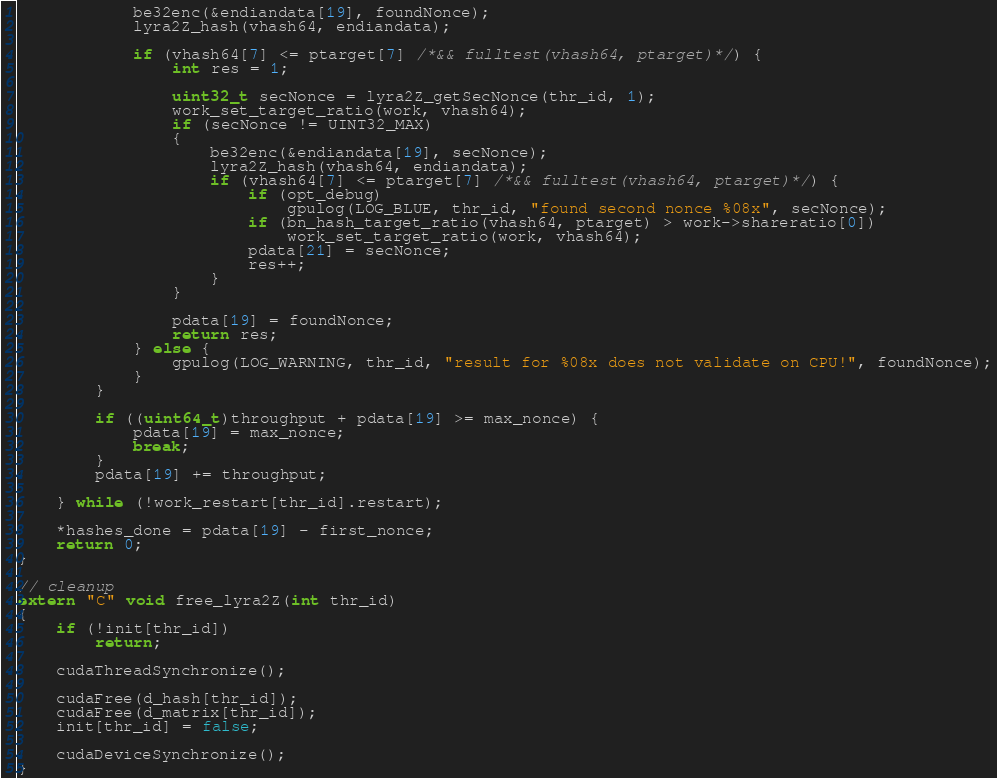<code> <loc_0><loc_0><loc_500><loc_500><_Cuda_>			be32enc(&endiandata[19], foundNonce); 
			lyra2Z_hash(vhash64, endiandata);  

			if (vhash64[7] <= ptarget[7] /*&& fulltest(vhash64, ptarget)*/) {
				int res = 1;
			
				uint32_t secNonce = lyra2Z_getSecNonce(thr_id, 1);
				work_set_target_ratio(work, vhash64);
				if (secNonce != UINT32_MAX)
				{
					be32enc(&endiandata[19], secNonce);
					lyra2Z_hash(vhash64, endiandata);
					if (vhash64[7] <= ptarget[7] /*&& fulltest(vhash64, ptarget)*/) {
						if (opt_debug)
							gpulog(LOG_BLUE, thr_id, "found second nonce %08x", secNonce);
						if (bn_hash_target_ratio(vhash64, ptarget) > work->shareratio[0])
							work_set_target_ratio(work, vhash64);
						pdata[21] = secNonce;
						res++;
					}
				}
			
				pdata[19] = foundNonce;
				return res;
			} else {
				gpulog(LOG_WARNING, thr_id, "result for %08x does not validate on CPU!", foundNonce);
			}
		}

		if ((uint64_t)throughput + pdata[19] >= max_nonce) {
			pdata[19] = max_nonce;
			break;
		}
		pdata[19] += throughput;

	} while (!work_restart[thr_id].restart);

	*hashes_done = pdata[19] - first_nonce;
	return 0;
}

// cleanup
extern "C" void free_lyra2Z(int thr_id)
{
	if (!init[thr_id])
		return;

	cudaThreadSynchronize();

	cudaFree(d_hash[thr_id]);
	cudaFree(d_matrix[thr_id]);
	init[thr_id] = false;

	cudaDeviceSynchronize();
}
</code> 